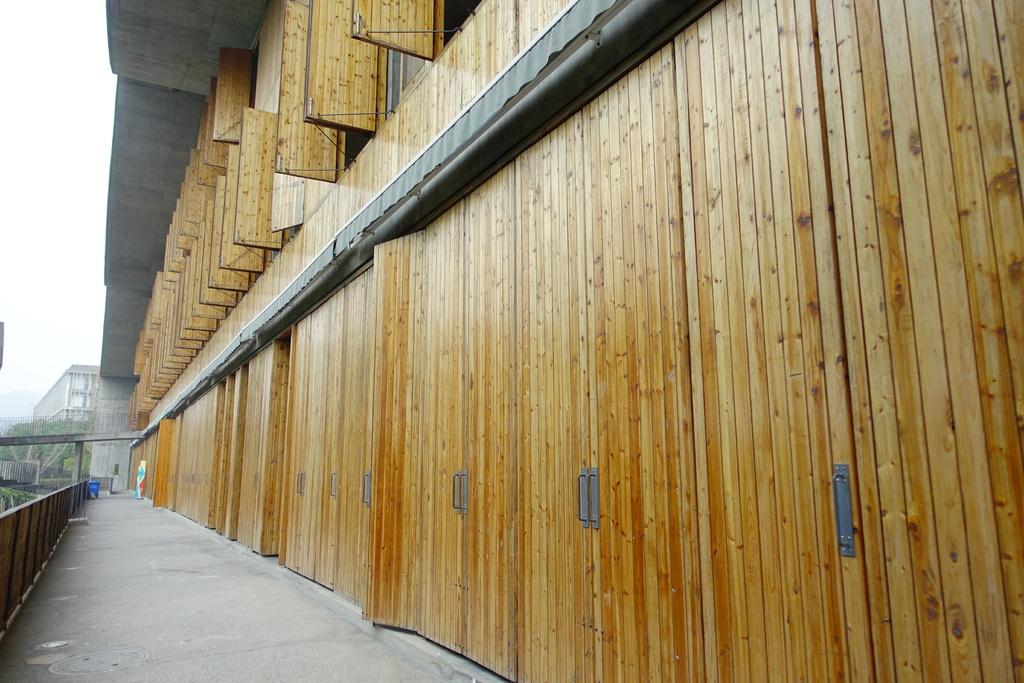What type of location is shown in the image? The image depicts a corridor of a building. What objects can be seen in the corridor? There are grills and a trash bin visible in the image. What type of vegetation is visible in the image? Trees are visible in the image. What part of the natural environment is visible in the image? The sky is visible in the image. What time is displayed on the flag in the image? There is no flag present in the image, so it is not possible to determine the time displayed on it. 